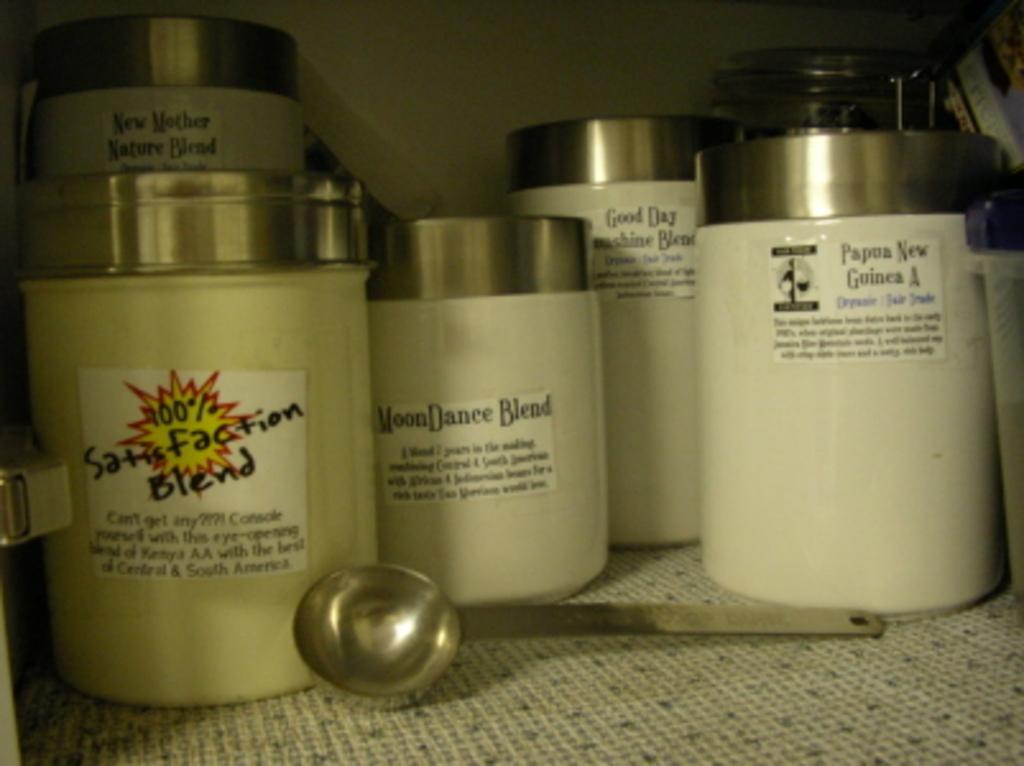What is the name on the first bottle from the left?
Your answer should be very brief. 100% satisfaction blend. 